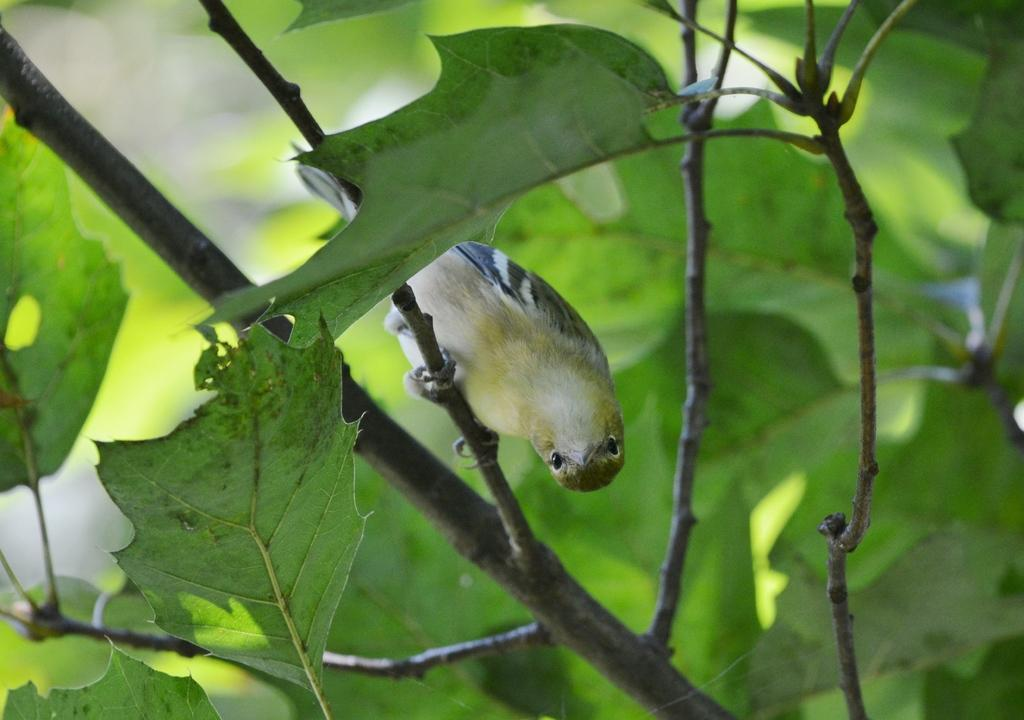What is the main object in the image? There is a branch of a tree in the image. What is the condition of the leaves on the branch? The branch has green leaves. Are there any animals visible in the image? Yes, there is a bird in the image. How would you describe the overall quality of the image? The image is slightly blurry in the background. What type of beetle can be seen crawling on the sticks in the image? There are no beetles or sticks present in the image; it features a branch with green leaves and a bird. What is the cause of the blurriness in the image? The cause of the blurriness in the image is not mentioned in the provided facts, so it cannot be determined from the image alone. 